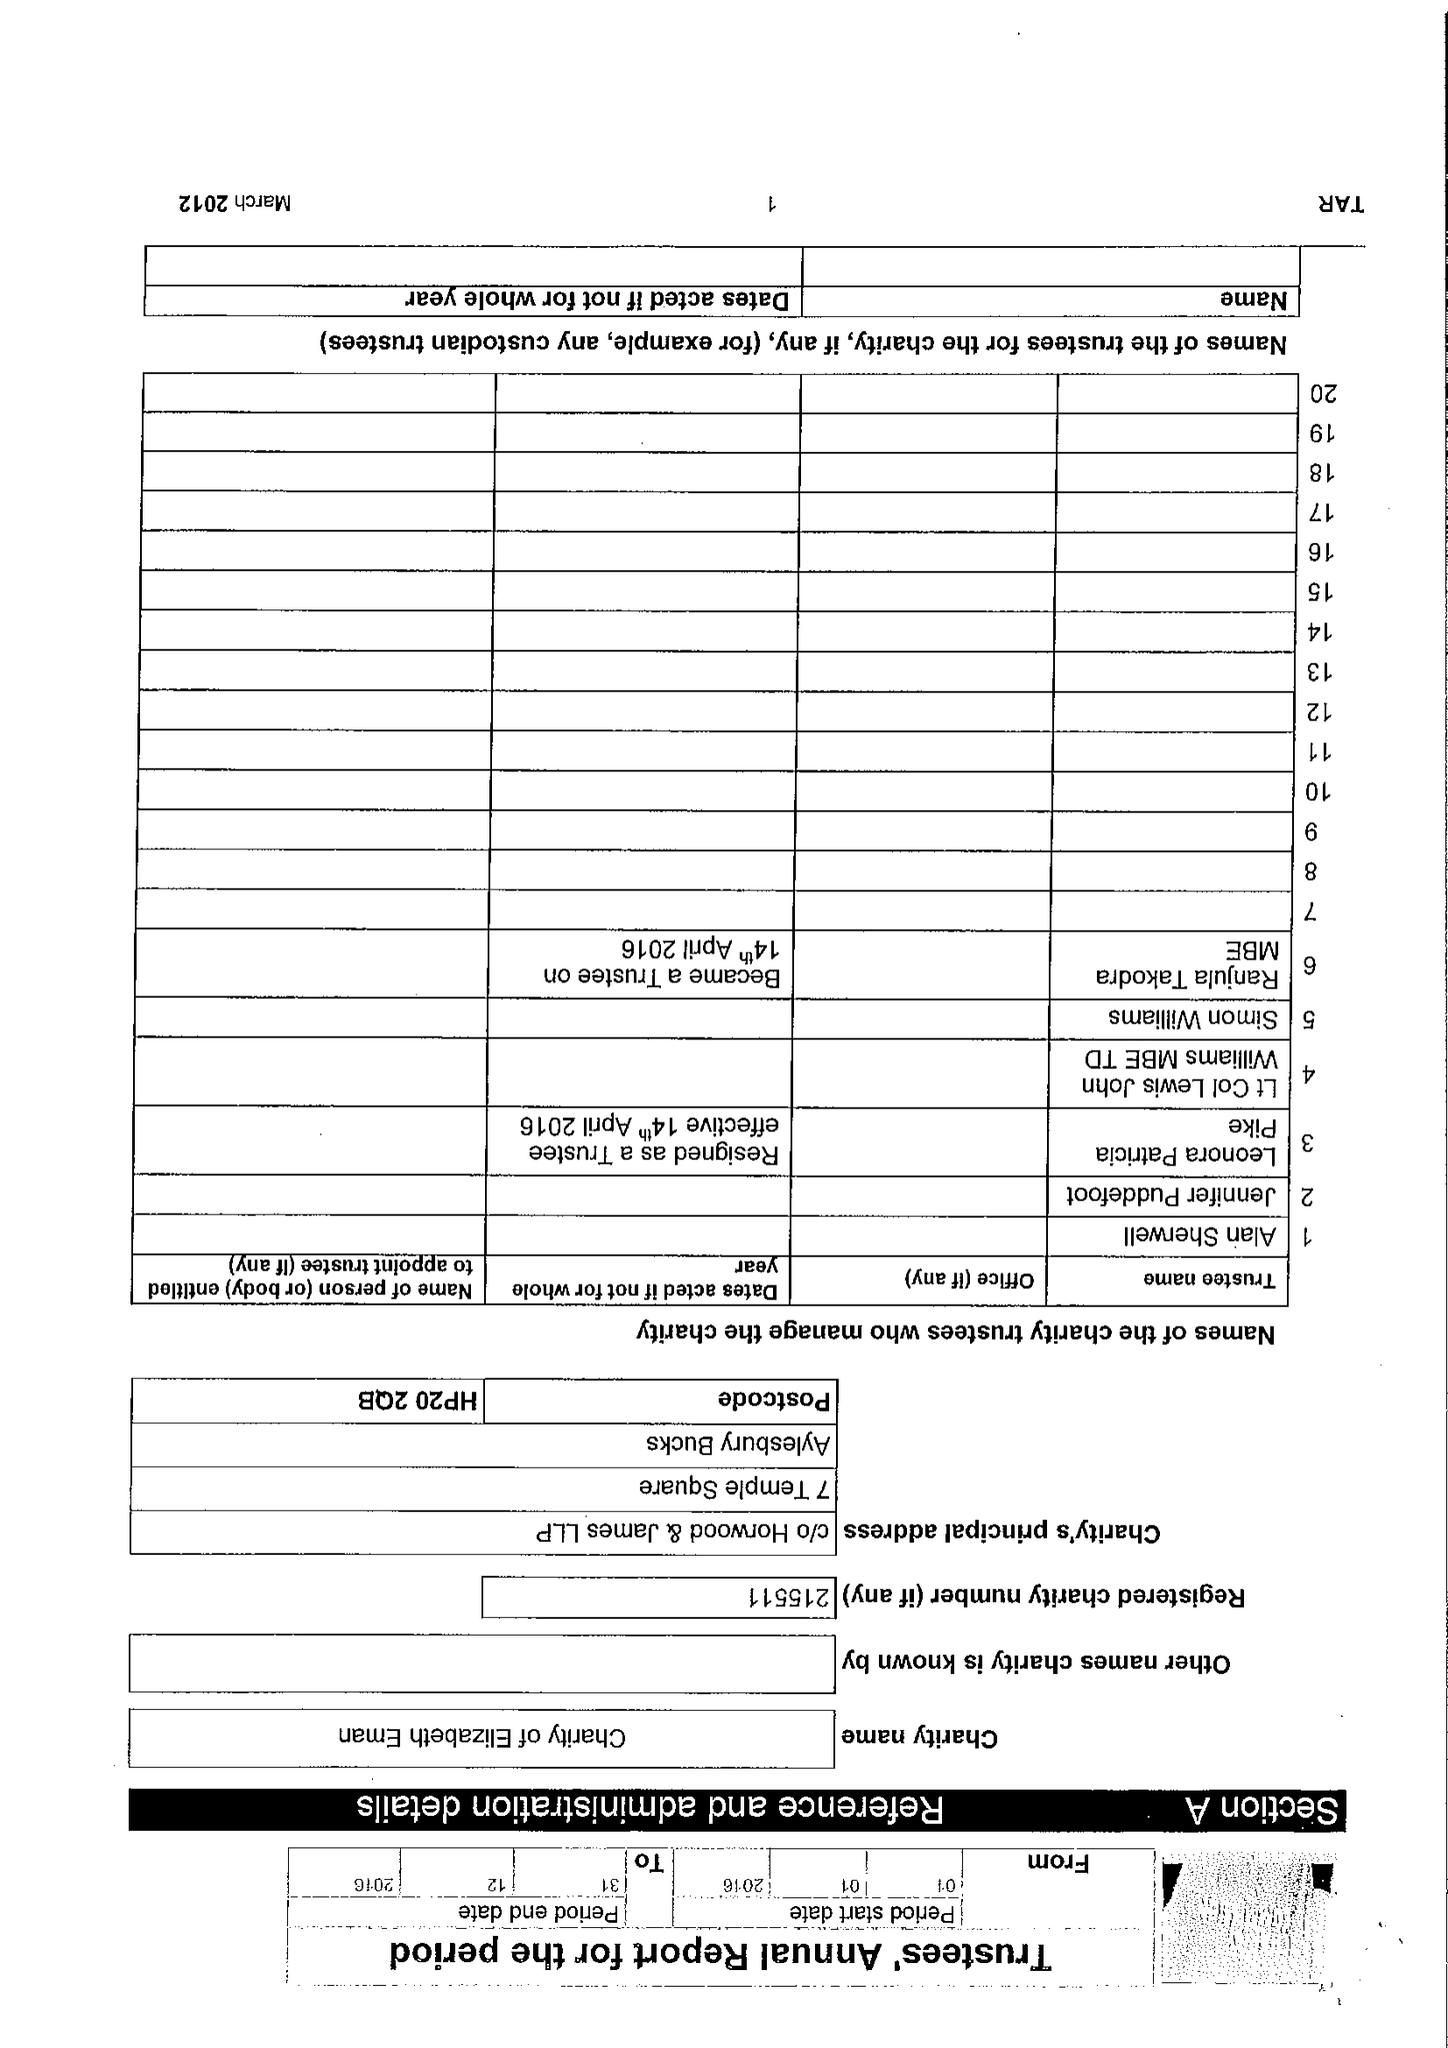What is the value for the spending_annually_in_british_pounds?
Answer the question using a single word or phrase. 67169.00 